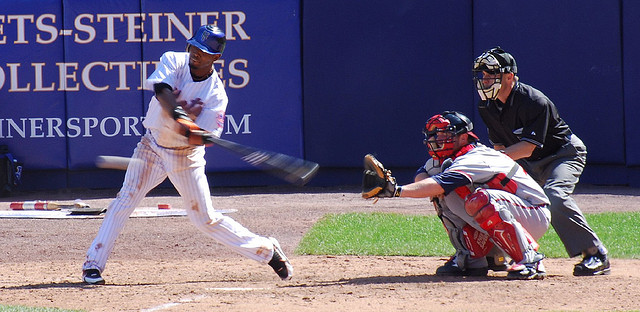Identify the text displayed in this image. -STEINER TS 